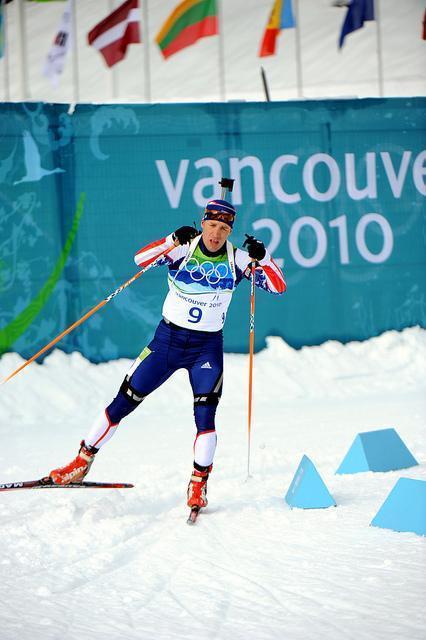How many train lights are turned on in this image?
Give a very brief answer. 0. 